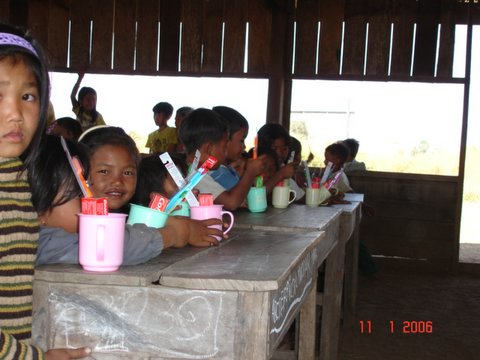<image>Which child is the most likely to be blamed for ruining the composition of this photograph? It's ambiguous to determine which child is most likely to be blamed for ruining the composition of the photograph. Which child is the most likely to be blamed for ruining the composition of this photograph? I don't know which child is the most likely to be blamed for ruining the composition of this photograph. It could be the middle child, the girl coming into the picture, or none of them. 